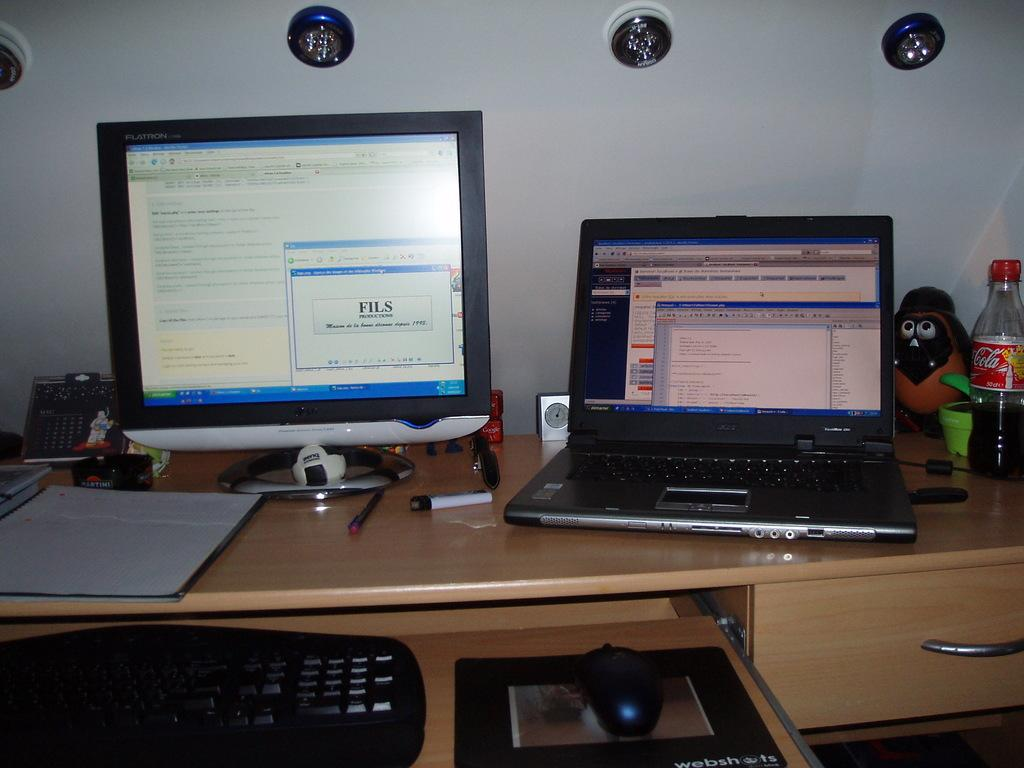What type of electronic device can be seen in the image? There is a computer and a laptop in the image. What accessories are present for the computer and laptop? There is a keyboard, a mouse, and a mouse pad in the image. What stationery item is visible in the image? There is a pen in the image. What type of paperwork is present in the image? There are papers in the image. What beverage container is in the image? There is a bottle in the image. What non-electronic toy is present in the image? There is a toy in the image. Where are the objects located in the image? The objects are on a table. What type of lighting is visible in the image? There are lights at the top of the image. What type of wilderness can be seen in the image? There is no wilderness present in the image; it features a table with various objects on it. How does the bat interact with the computer in the image? There is no bat present in the image; it only features a computer, laptop, and other related items. 